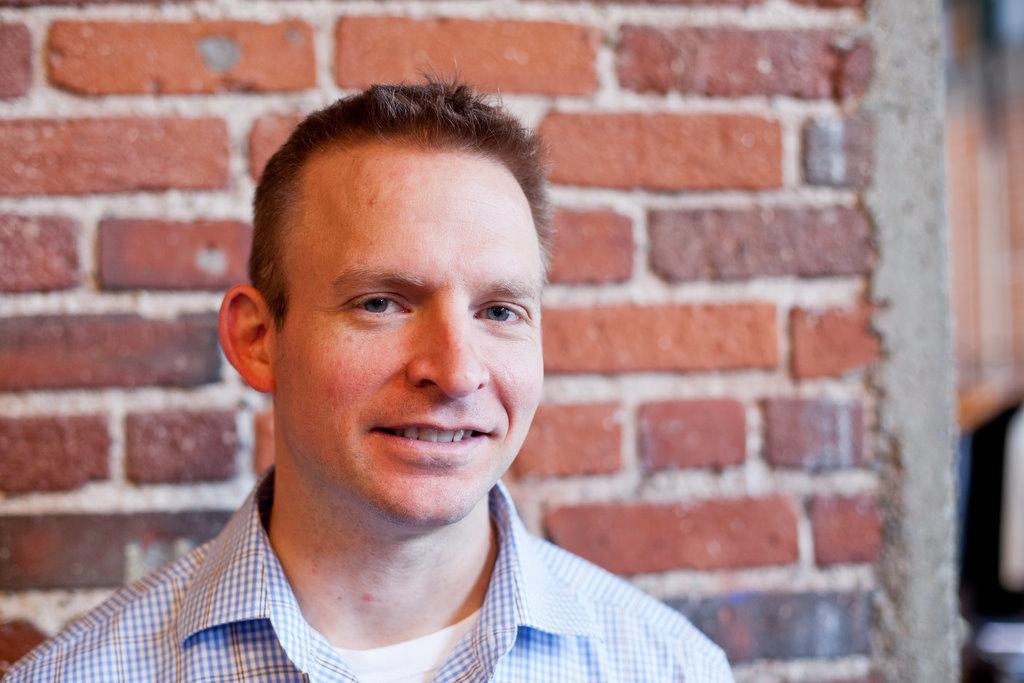In one or two sentences, can you explain what this image depicts? In the foreground of the image there is a person. In the background of the image there is wall. 